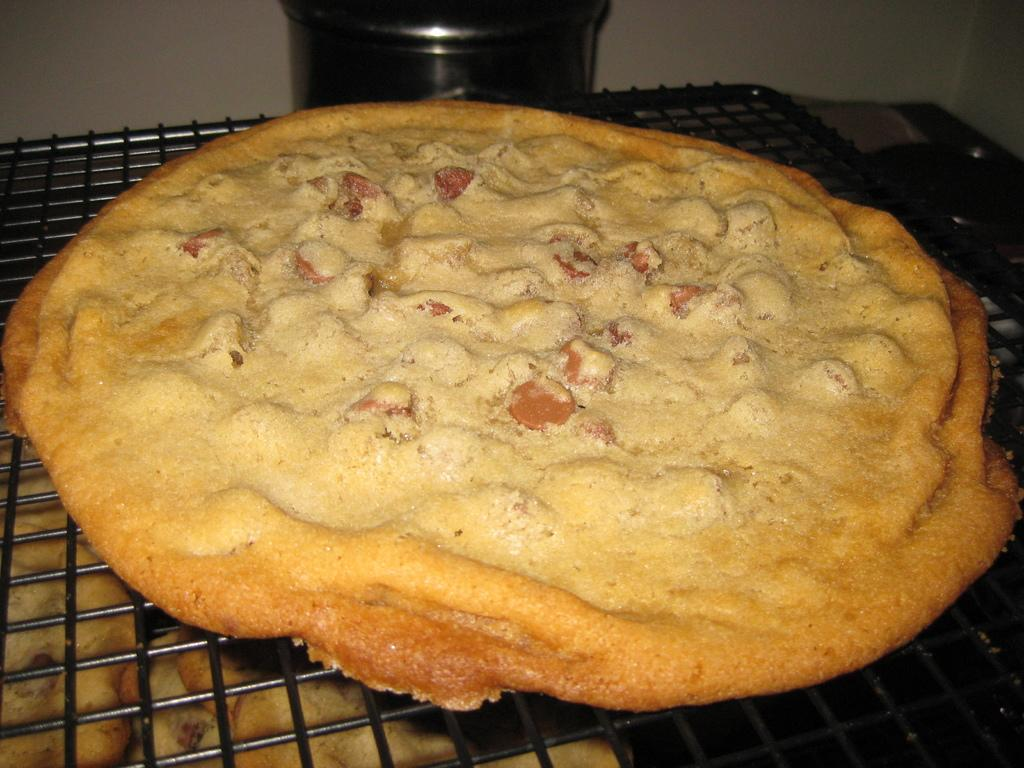What is the main object in the image? There is a grill in the image. What is happening to the food item in the image? A food item is present on the grill. Is there anything else on the grill besides the food item? Yes, there is a vessel on the grill. What can be seen in the background of the image? There is a vessel in the background of the image. What is located below the grill? There are food items below the grill. Can you see a frog sitting on the grill in the image? No, there is no frog present in the image. What type of fuel is being used to power the grill in the image? The image does not provide information about the type of fuel being used for the grill. 